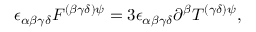Convert formula to latex. <formula><loc_0><loc_0><loc_500><loc_500>\epsilon _ { \alpha \beta \gamma \delta } F ^ { ( \beta \gamma \delta ) \psi } = 3 \epsilon _ { \alpha \beta \gamma \delta } \partial ^ { \beta } T ^ { ( \gamma \delta ) \psi } ,</formula> 